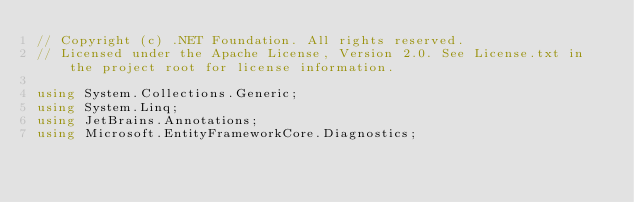<code> <loc_0><loc_0><loc_500><loc_500><_C#_>// Copyright (c) .NET Foundation. All rights reserved.
// Licensed under the Apache License, Version 2.0. See License.txt in the project root for license information.

using System.Collections.Generic;
using System.Linq;
using JetBrains.Annotations;
using Microsoft.EntityFrameworkCore.Diagnostics;</code> 